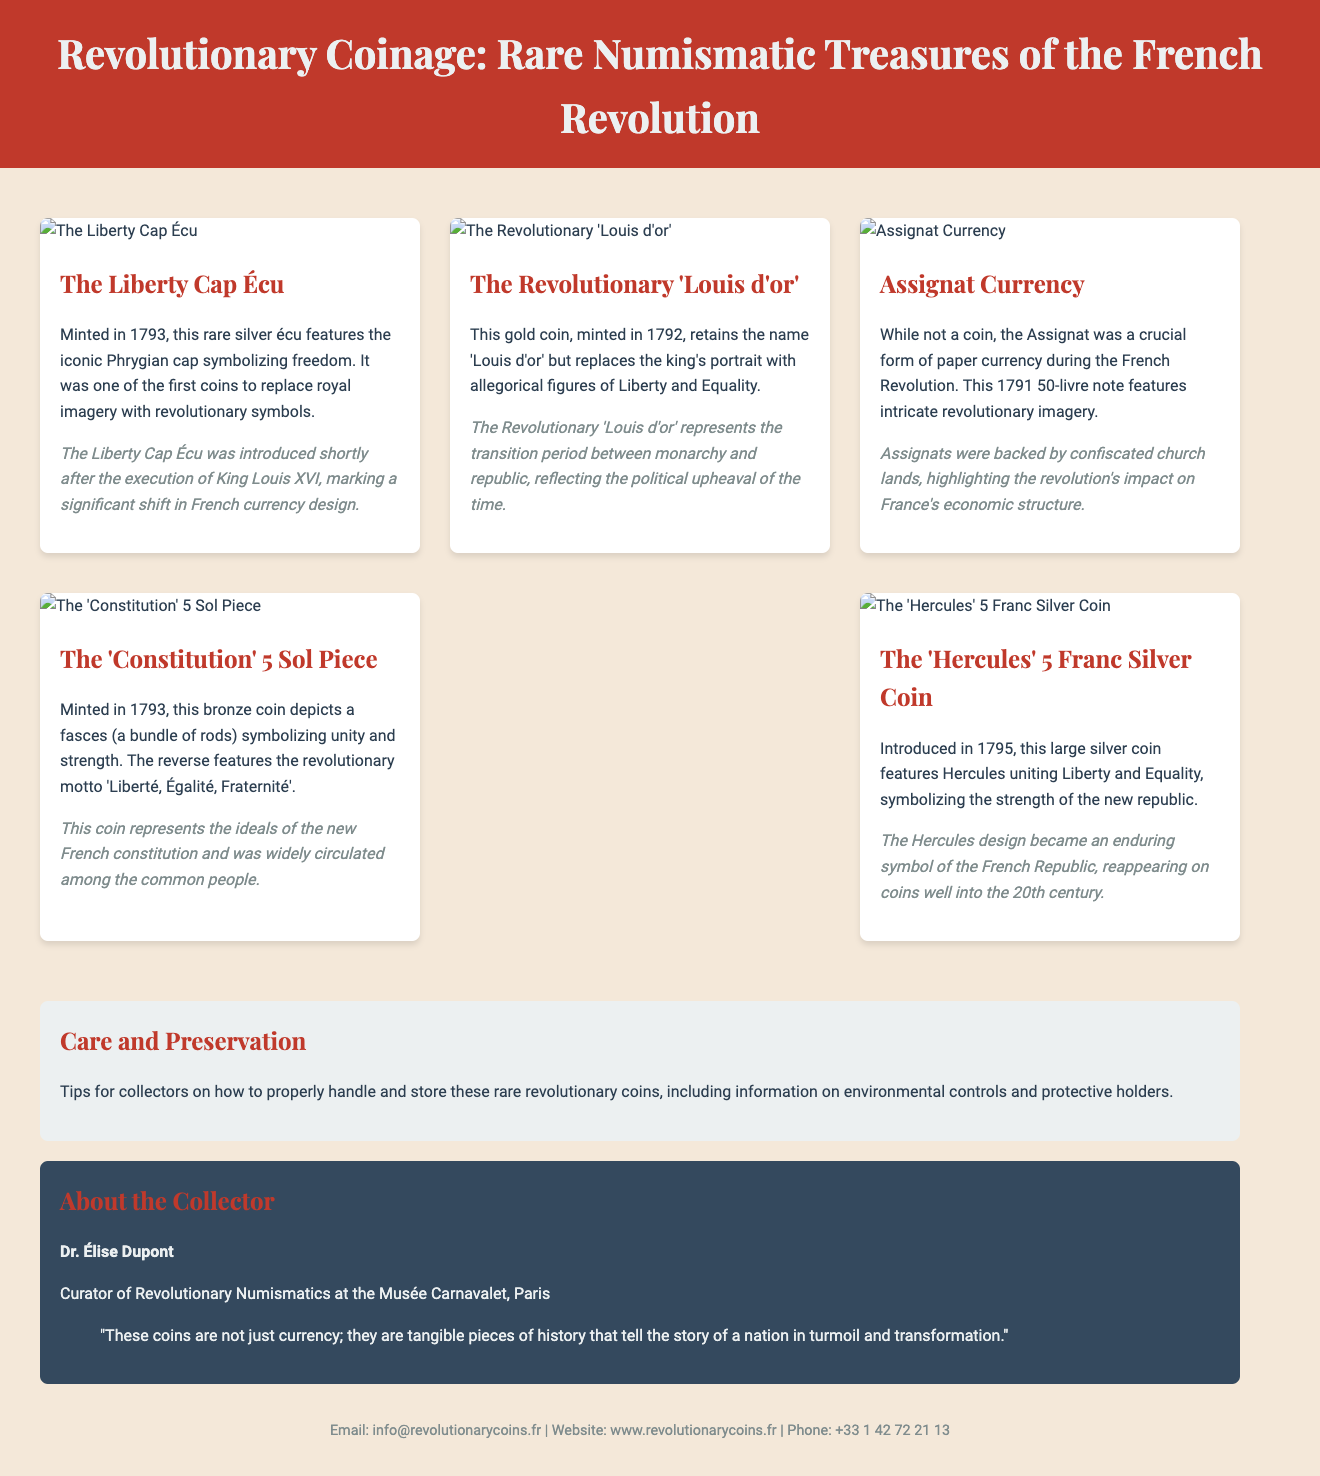What coin features the Phrygian cap? The brochure describes the Liberty Cap Écu, which features the Phrygian cap symbolizing freedom.
Answer: Liberty Cap Écu In what year was the Revolutionary 'Louis d'or' minted? The brochure states that the Revolutionary 'Louis d'or' was minted in 1792.
Answer: 1792 What does the reverse of the 'Constitution' 5 Sol Piece feature? The reverse of this coin features the revolutionary motto 'Liberté, Égalité, Fraternité'.
Answer: Liberté, Égalité, Fraternité Who is the curator mentioned in the brochure? The brochure provides the name and credentials of Dr. Élise Dupont as the curator of Revolutionary Numismatics at the Musée Carnavalet.
Answer: Dr. Élise Dupont What type of currency is the Assignat considered? The brochure explicitly describes the Assignat as a crucial form of paper currency during the French Revolution.
Answer: Paper currency What major change did the Liberty Cap Écu represent in French currency design? The brochure indicates that it marked a shift from royal imagery to revolutionary symbols.
Answer: Shift in imagery What is a key aspect of caring for rare coins mentioned in the brochure? The brochure includes tips on how to properly handle and store these coins.
Answer: Proper handling and storage Which coin was introduced in 1795? The Hercules 5 Franc Silver Coin is mentioned as being introduced in 1795.
Answer: Hercules 5 Franc Silver Coin What does the term 'Assignat' refer to regarding its backing? The historical context indicates that Assignats were backed by confiscated church lands.
Answer: Confiscated church lands How can collectors contact the organization? The contact information section includes email, website, and phone for inquiries.
Answer: Email, website, and phone 